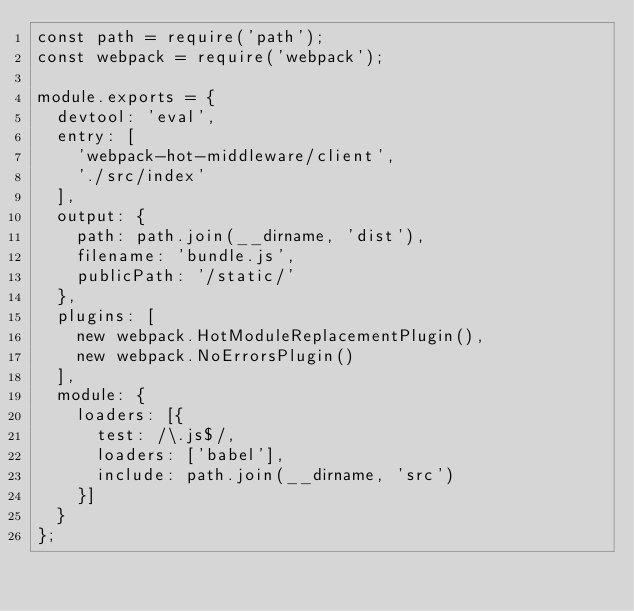Convert code to text. <code><loc_0><loc_0><loc_500><loc_500><_JavaScript_>const path = require('path');
const webpack = require('webpack');

module.exports = {
  devtool: 'eval',
  entry: [
    'webpack-hot-middleware/client',
    './src/index'
  ],
  output: {
    path: path.join(__dirname, 'dist'),
    filename: 'bundle.js',
    publicPath: '/static/'
  },
  plugins: [
    new webpack.HotModuleReplacementPlugin(),
    new webpack.NoErrorsPlugin()
  ],
  module: {
    loaders: [{
      test: /\.js$/,
      loaders: ['babel'],
      include: path.join(__dirname, 'src')
    }]
  }
};
</code> 